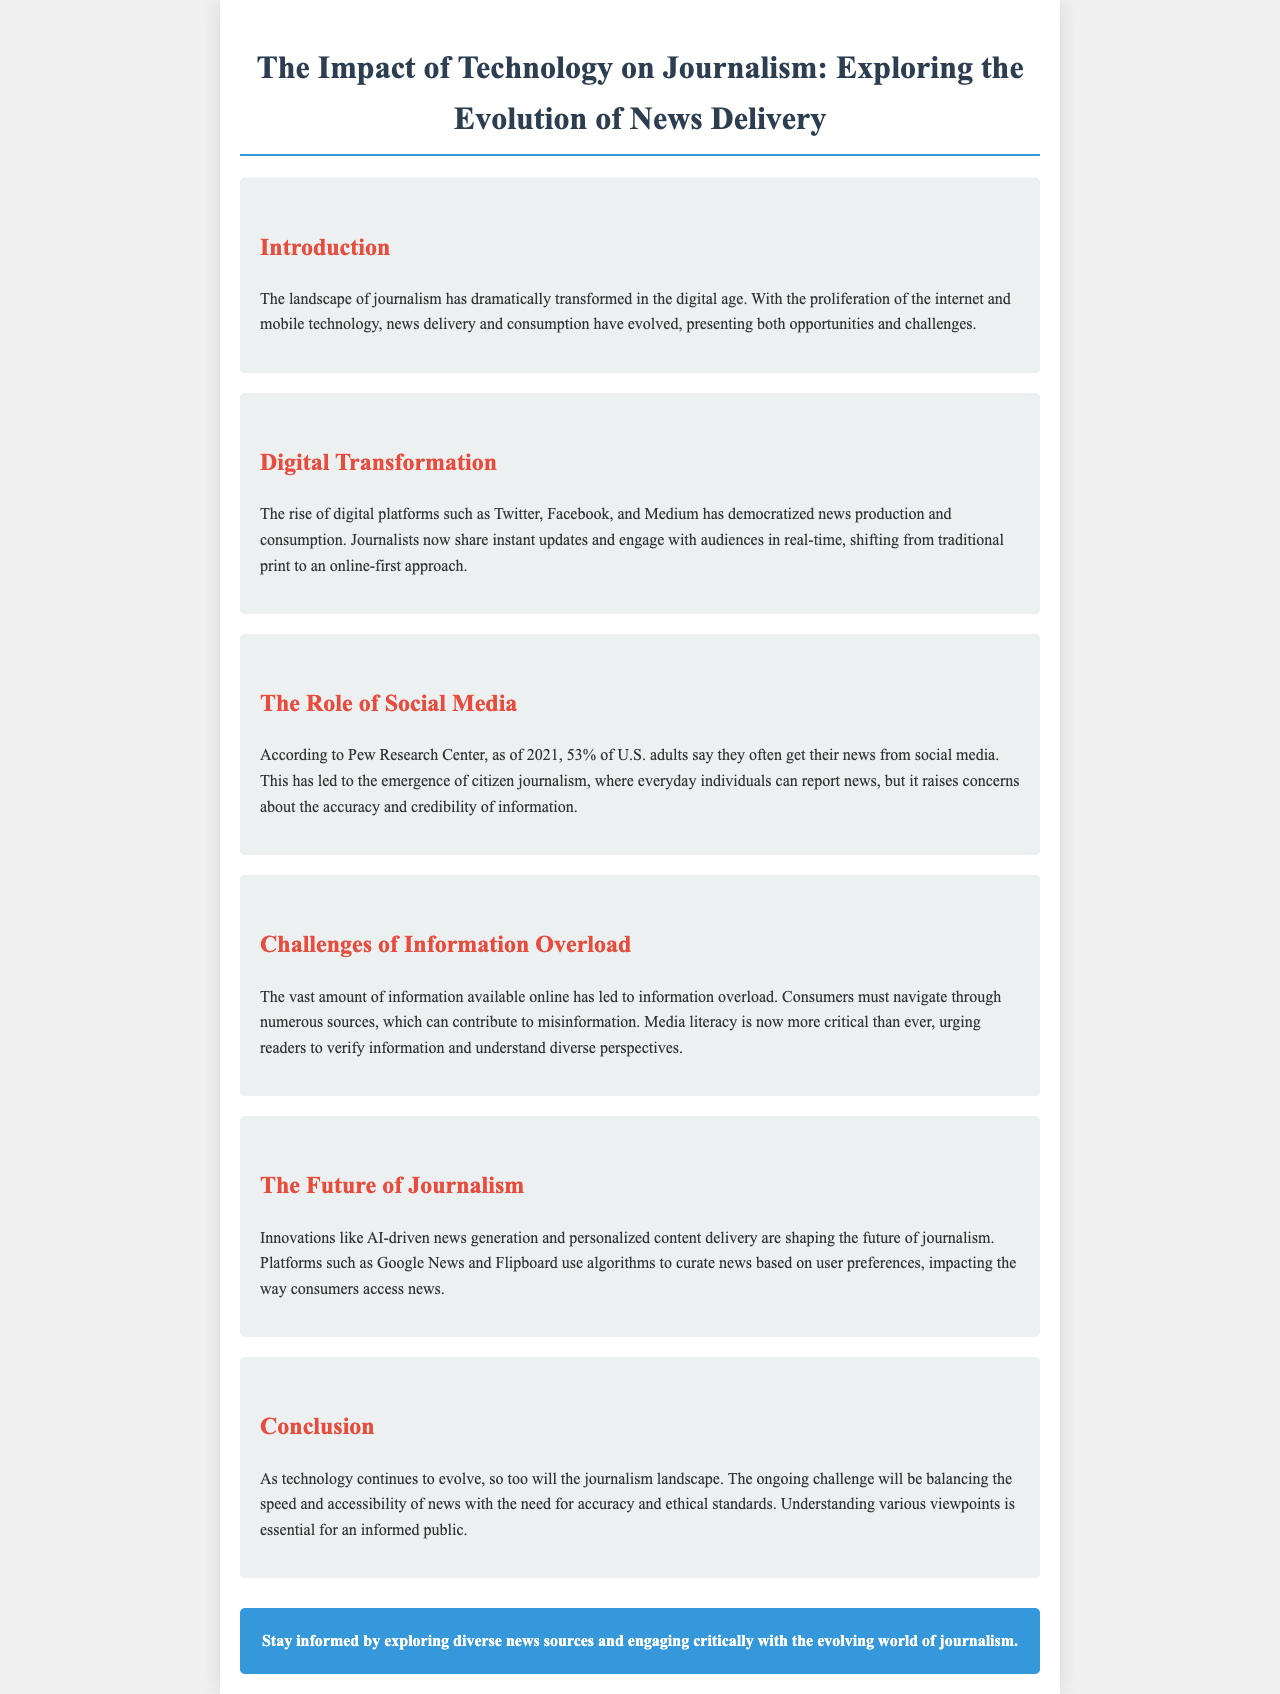what percentage of U.S. adults often get news from social media? The document states that 53% of U.S. adults say they often get their news from social media, according to Pew Research Center.
Answer: 53% what is one challenge mentioned about information available online? The document mentions that the vast amount of information available online has led to information overload.
Answer: information overload which technology is shaping the future of journalism? The document discusses innovations like AI-driven news generation as shaping the future of journalism.
Answer: AI-driven news generation what is the primary concern regarding citizen journalism? The document raises concerns about the accuracy and credibility of information in relation to citizen journalism.
Answer: accuracy and credibility what is the call to action provided at the end of the brochure? The call to action urges readers to stay informed by exploring diverse news sources and engaging critically with journalism.
Answer: Explore diverse news sources what shift in journalism is emphasized in the document? The document emphasizes a shift from traditional print to an online-first approach in journalism.
Answer: online-first approach which digital platforms are mentioned as part of digital transformation? The document lists platforms like Twitter, Facebook, and Medium as part of digital transformation.
Answer: Twitter, Facebook, and Medium what is the role of media literacy according to the document? The document states that media literacy is critical for readers to verify information and understand diverse perspectives.
Answer: critical for verifying information 